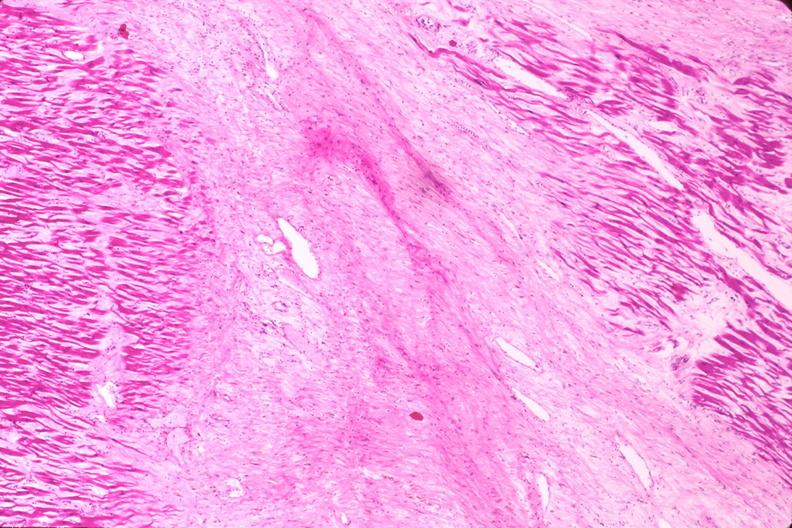what does this image show?
Answer the question using a single word or phrase. Heart 